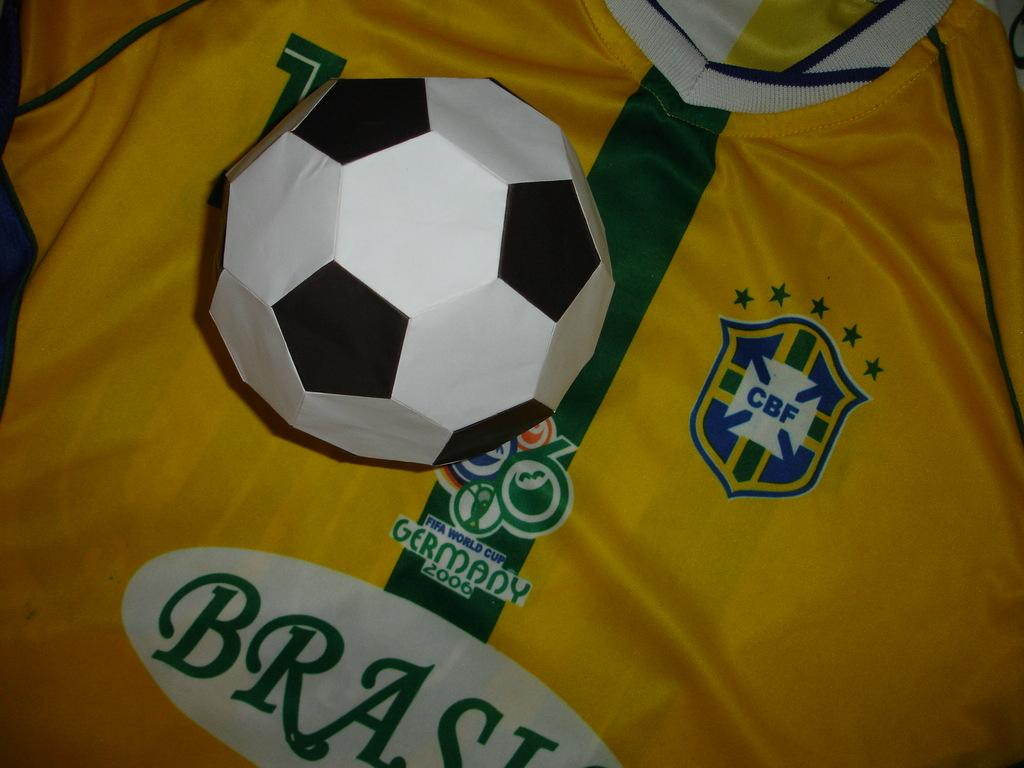<image>
Provide a brief description of the given image. a jersey that is for the Brasil soccer team 